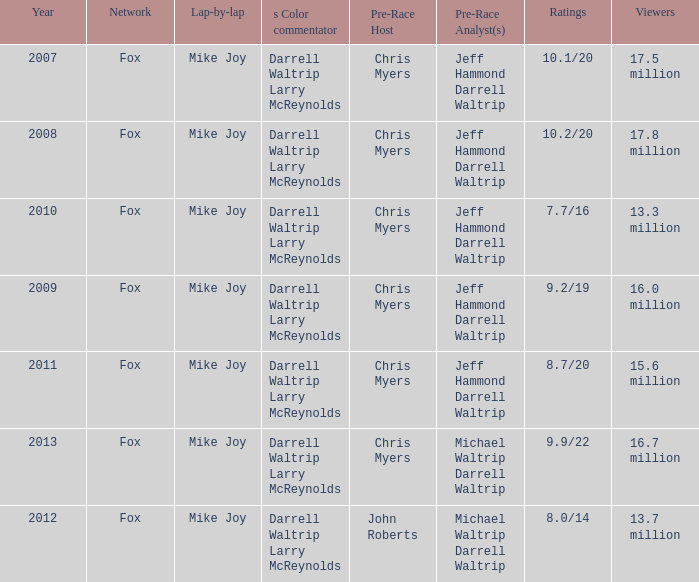What Lap-by-lap has Chris Myers as the Pre-Race Host, a Year larger than 2008, and 9.9/22 as its Ratings? Mike Joy. 